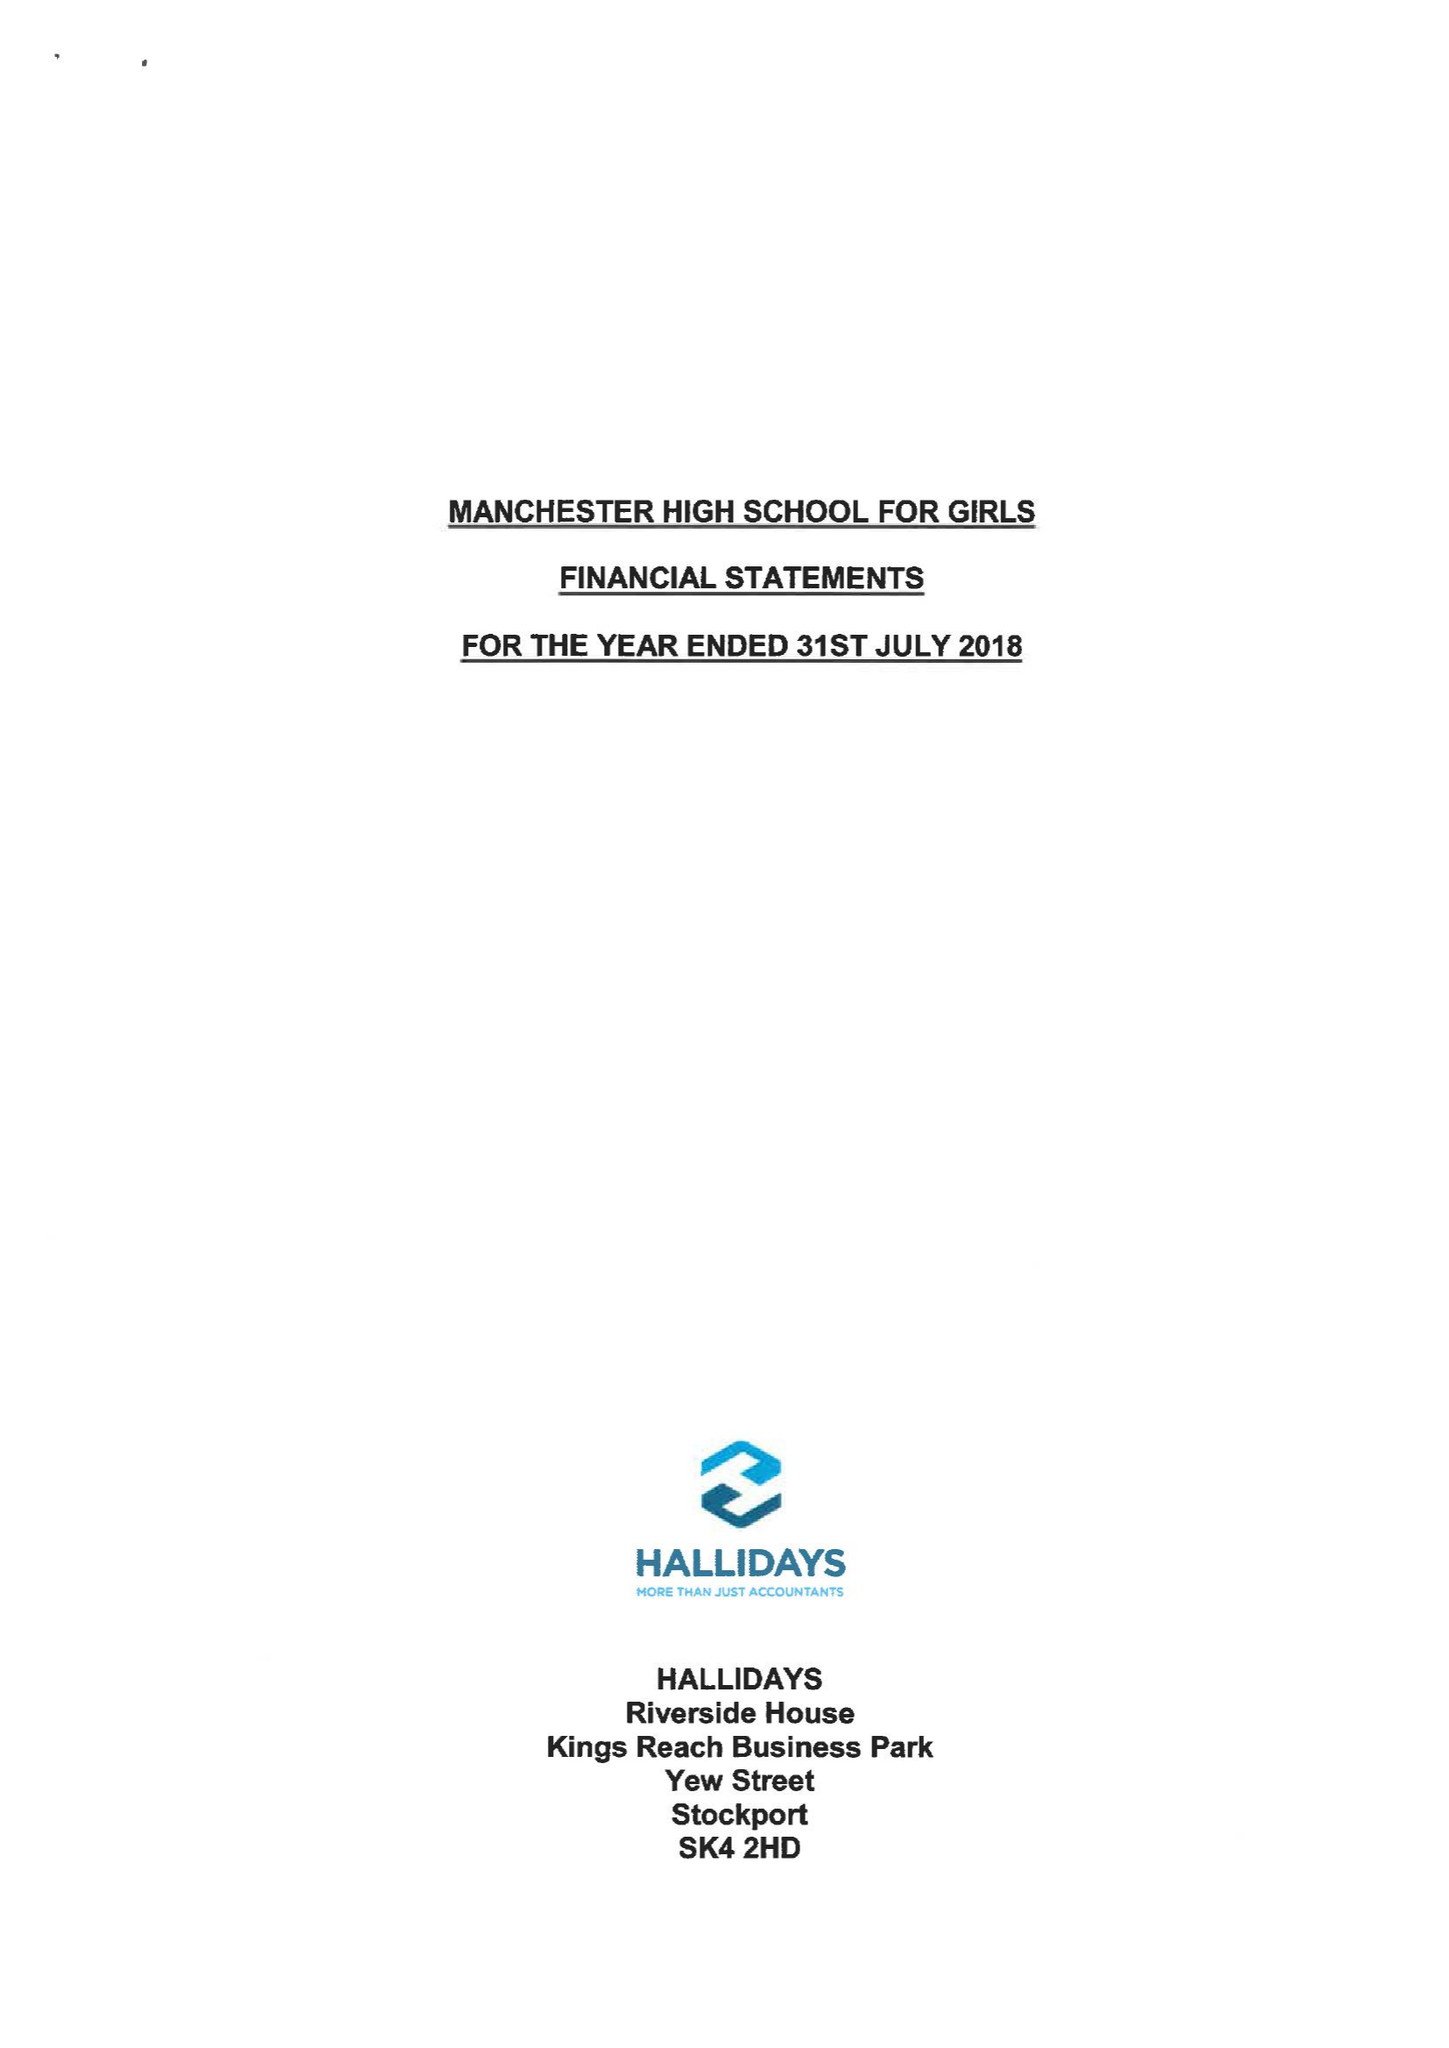What is the value for the address__street_line?
Answer the question using a single word or phrase. GRANGETHORPE ROAD 